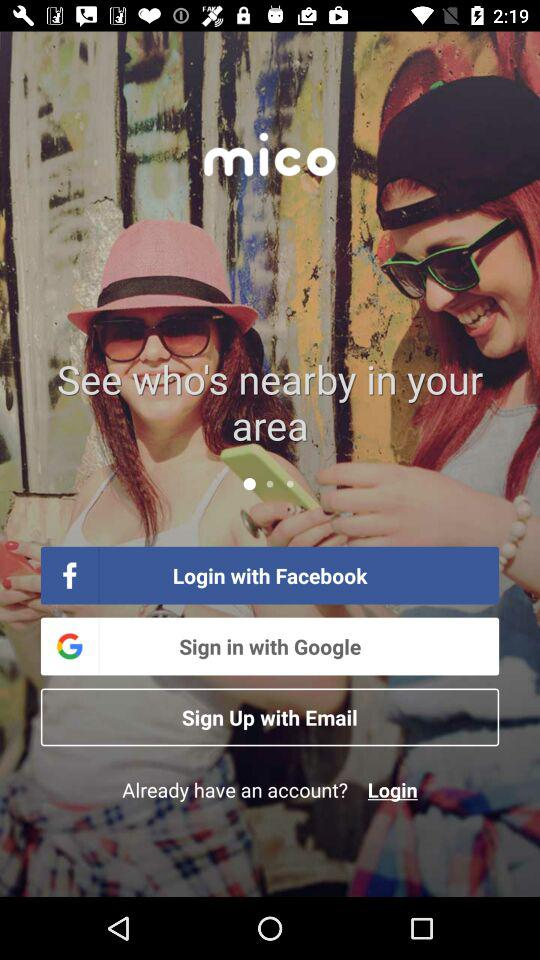How many sign in options are available?
Answer the question using a single word or phrase. 3 